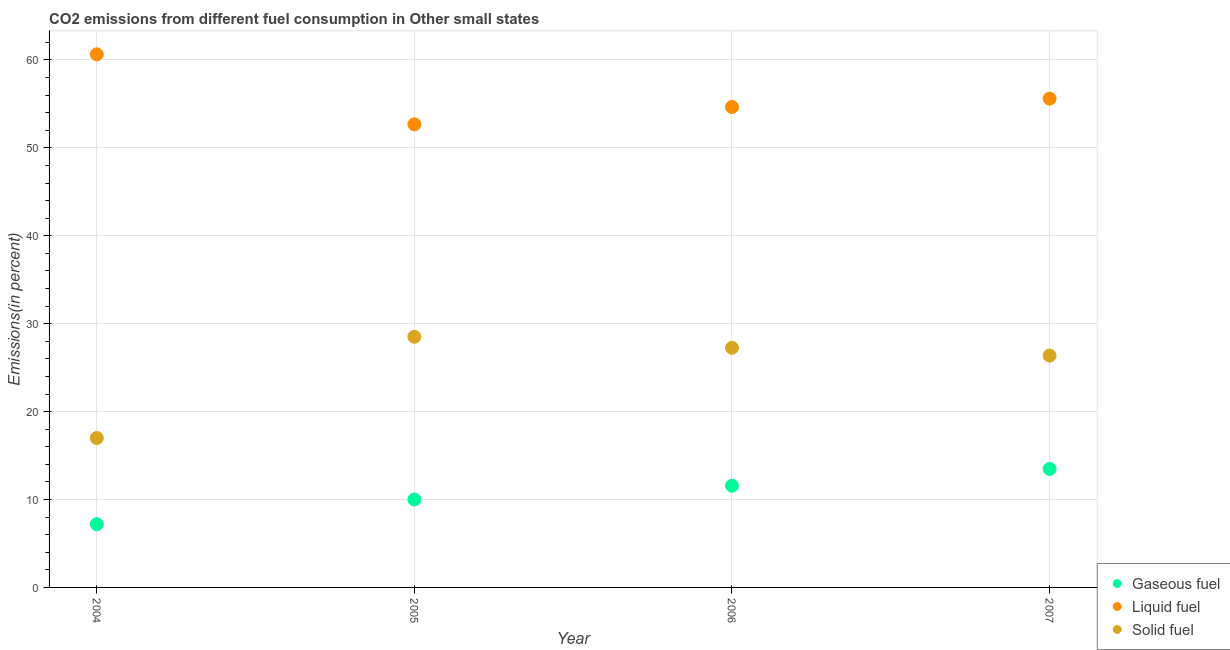How many different coloured dotlines are there?
Your answer should be very brief. 3. What is the percentage of gaseous fuel emission in 2007?
Provide a short and direct response. 13.48. Across all years, what is the maximum percentage of solid fuel emission?
Keep it short and to the point. 28.51. Across all years, what is the minimum percentage of gaseous fuel emission?
Your answer should be very brief. 7.19. In which year was the percentage of liquid fuel emission minimum?
Offer a very short reply. 2005. What is the total percentage of liquid fuel emission in the graph?
Make the answer very short. 223.56. What is the difference between the percentage of gaseous fuel emission in 2005 and that in 2006?
Provide a succinct answer. -1.57. What is the difference between the percentage of liquid fuel emission in 2007 and the percentage of gaseous fuel emission in 2004?
Your answer should be compact. 48.41. What is the average percentage of solid fuel emission per year?
Ensure brevity in your answer.  24.78. In the year 2007, what is the difference between the percentage of liquid fuel emission and percentage of solid fuel emission?
Offer a terse response. 29.23. What is the ratio of the percentage of gaseous fuel emission in 2005 to that in 2007?
Ensure brevity in your answer.  0.74. Is the percentage of solid fuel emission in 2006 less than that in 2007?
Offer a very short reply. No. Is the difference between the percentage of gaseous fuel emission in 2004 and 2007 greater than the difference between the percentage of solid fuel emission in 2004 and 2007?
Keep it short and to the point. Yes. What is the difference between the highest and the second highest percentage of gaseous fuel emission?
Offer a terse response. 1.91. What is the difference between the highest and the lowest percentage of solid fuel emission?
Your answer should be compact. 11.51. Is the sum of the percentage of gaseous fuel emission in 2004 and 2007 greater than the maximum percentage of solid fuel emission across all years?
Offer a terse response. No. Is it the case that in every year, the sum of the percentage of gaseous fuel emission and percentage of liquid fuel emission is greater than the percentage of solid fuel emission?
Ensure brevity in your answer.  Yes. Does the percentage of solid fuel emission monotonically increase over the years?
Offer a terse response. No. Is the percentage of liquid fuel emission strictly greater than the percentage of gaseous fuel emission over the years?
Ensure brevity in your answer.  Yes. Is the percentage of solid fuel emission strictly less than the percentage of gaseous fuel emission over the years?
Give a very brief answer. No. How many dotlines are there?
Keep it short and to the point. 3. How many years are there in the graph?
Your response must be concise. 4. Are the values on the major ticks of Y-axis written in scientific E-notation?
Make the answer very short. No. Does the graph contain grids?
Your response must be concise. Yes. Where does the legend appear in the graph?
Make the answer very short. Bottom right. What is the title of the graph?
Offer a terse response. CO2 emissions from different fuel consumption in Other small states. Does "Injury" appear as one of the legend labels in the graph?
Keep it short and to the point. No. What is the label or title of the Y-axis?
Your response must be concise. Emissions(in percent). What is the Emissions(in percent) in Gaseous fuel in 2004?
Your response must be concise. 7.19. What is the Emissions(in percent) in Liquid fuel in 2004?
Keep it short and to the point. 60.64. What is the Emissions(in percent) in Solid fuel in 2004?
Your response must be concise. 17. What is the Emissions(in percent) in Gaseous fuel in 2005?
Ensure brevity in your answer.  10. What is the Emissions(in percent) of Liquid fuel in 2005?
Your answer should be compact. 52.68. What is the Emissions(in percent) in Solid fuel in 2005?
Offer a terse response. 28.51. What is the Emissions(in percent) of Gaseous fuel in 2006?
Offer a terse response. 11.57. What is the Emissions(in percent) in Liquid fuel in 2006?
Provide a short and direct response. 54.65. What is the Emissions(in percent) of Solid fuel in 2006?
Provide a succinct answer. 27.26. What is the Emissions(in percent) of Gaseous fuel in 2007?
Provide a succinct answer. 13.48. What is the Emissions(in percent) in Liquid fuel in 2007?
Make the answer very short. 55.6. What is the Emissions(in percent) in Solid fuel in 2007?
Your response must be concise. 26.37. Across all years, what is the maximum Emissions(in percent) of Gaseous fuel?
Your answer should be compact. 13.48. Across all years, what is the maximum Emissions(in percent) of Liquid fuel?
Make the answer very short. 60.64. Across all years, what is the maximum Emissions(in percent) in Solid fuel?
Make the answer very short. 28.51. Across all years, what is the minimum Emissions(in percent) in Gaseous fuel?
Give a very brief answer. 7.19. Across all years, what is the minimum Emissions(in percent) in Liquid fuel?
Your answer should be compact. 52.68. Across all years, what is the minimum Emissions(in percent) in Solid fuel?
Your answer should be very brief. 17. What is the total Emissions(in percent) in Gaseous fuel in the graph?
Your answer should be very brief. 42.24. What is the total Emissions(in percent) in Liquid fuel in the graph?
Provide a short and direct response. 223.56. What is the total Emissions(in percent) of Solid fuel in the graph?
Your response must be concise. 99.14. What is the difference between the Emissions(in percent) of Gaseous fuel in 2004 and that in 2005?
Keep it short and to the point. -2.81. What is the difference between the Emissions(in percent) in Liquid fuel in 2004 and that in 2005?
Ensure brevity in your answer.  7.96. What is the difference between the Emissions(in percent) of Solid fuel in 2004 and that in 2005?
Ensure brevity in your answer.  -11.51. What is the difference between the Emissions(in percent) of Gaseous fuel in 2004 and that in 2006?
Your response must be concise. -4.38. What is the difference between the Emissions(in percent) in Liquid fuel in 2004 and that in 2006?
Provide a short and direct response. 5.99. What is the difference between the Emissions(in percent) of Solid fuel in 2004 and that in 2006?
Provide a succinct answer. -10.26. What is the difference between the Emissions(in percent) of Gaseous fuel in 2004 and that in 2007?
Give a very brief answer. -6.29. What is the difference between the Emissions(in percent) in Liquid fuel in 2004 and that in 2007?
Offer a terse response. 5.04. What is the difference between the Emissions(in percent) of Solid fuel in 2004 and that in 2007?
Your answer should be compact. -9.37. What is the difference between the Emissions(in percent) in Gaseous fuel in 2005 and that in 2006?
Make the answer very short. -1.57. What is the difference between the Emissions(in percent) in Liquid fuel in 2005 and that in 2006?
Your answer should be compact. -1.97. What is the difference between the Emissions(in percent) in Solid fuel in 2005 and that in 2006?
Offer a terse response. 1.25. What is the difference between the Emissions(in percent) of Gaseous fuel in 2005 and that in 2007?
Your response must be concise. -3.48. What is the difference between the Emissions(in percent) of Liquid fuel in 2005 and that in 2007?
Make the answer very short. -2.92. What is the difference between the Emissions(in percent) in Solid fuel in 2005 and that in 2007?
Give a very brief answer. 2.14. What is the difference between the Emissions(in percent) in Gaseous fuel in 2006 and that in 2007?
Give a very brief answer. -1.91. What is the difference between the Emissions(in percent) in Liquid fuel in 2006 and that in 2007?
Keep it short and to the point. -0.95. What is the difference between the Emissions(in percent) in Solid fuel in 2006 and that in 2007?
Provide a short and direct response. 0.89. What is the difference between the Emissions(in percent) in Gaseous fuel in 2004 and the Emissions(in percent) in Liquid fuel in 2005?
Your response must be concise. -45.48. What is the difference between the Emissions(in percent) of Gaseous fuel in 2004 and the Emissions(in percent) of Solid fuel in 2005?
Your response must be concise. -21.32. What is the difference between the Emissions(in percent) in Liquid fuel in 2004 and the Emissions(in percent) in Solid fuel in 2005?
Your answer should be compact. 32.13. What is the difference between the Emissions(in percent) in Gaseous fuel in 2004 and the Emissions(in percent) in Liquid fuel in 2006?
Keep it short and to the point. -47.46. What is the difference between the Emissions(in percent) in Gaseous fuel in 2004 and the Emissions(in percent) in Solid fuel in 2006?
Provide a short and direct response. -20.07. What is the difference between the Emissions(in percent) in Liquid fuel in 2004 and the Emissions(in percent) in Solid fuel in 2006?
Make the answer very short. 33.38. What is the difference between the Emissions(in percent) of Gaseous fuel in 2004 and the Emissions(in percent) of Liquid fuel in 2007?
Your answer should be compact. -48.41. What is the difference between the Emissions(in percent) of Gaseous fuel in 2004 and the Emissions(in percent) of Solid fuel in 2007?
Your answer should be very brief. -19.18. What is the difference between the Emissions(in percent) of Liquid fuel in 2004 and the Emissions(in percent) of Solid fuel in 2007?
Ensure brevity in your answer.  34.27. What is the difference between the Emissions(in percent) of Gaseous fuel in 2005 and the Emissions(in percent) of Liquid fuel in 2006?
Offer a terse response. -44.65. What is the difference between the Emissions(in percent) of Gaseous fuel in 2005 and the Emissions(in percent) of Solid fuel in 2006?
Your answer should be compact. -17.26. What is the difference between the Emissions(in percent) in Liquid fuel in 2005 and the Emissions(in percent) in Solid fuel in 2006?
Make the answer very short. 25.42. What is the difference between the Emissions(in percent) of Gaseous fuel in 2005 and the Emissions(in percent) of Liquid fuel in 2007?
Give a very brief answer. -45.6. What is the difference between the Emissions(in percent) in Gaseous fuel in 2005 and the Emissions(in percent) in Solid fuel in 2007?
Make the answer very short. -16.37. What is the difference between the Emissions(in percent) in Liquid fuel in 2005 and the Emissions(in percent) in Solid fuel in 2007?
Your response must be concise. 26.31. What is the difference between the Emissions(in percent) in Gaseous fuel in 2006 and the Emissions(in percent) in Liquid fuel in 2007?
Your answer should be compact. -44.03. What is the difference between the Emissions(in percent) of Gaseous fuel in 2006 and the Emissions(in percent) of Solid fuel in 2007?
Provide a short and direct response. -14.8. What is the difference between the Emissions(in percent) in Liquid fuel in 2006 and the Emissions(in percent) in Solid fuel in 2007?
Your answer should be compact. 28.28. What is the average Emissions(in percent) in Gaseous fuel per year?
Offer a terse response. 10.56. What is the average Emissions(in percent) in Liquid fuel per year?
Make the answer very short. 55.89. What is the average Emissions(in percent) of Solid fuel per year?
Ensure brevity in your answer.  24.78. In the year 2004, what is the difference between the Emissions(in percent) in Gaseous fuel and Emissions(in percent) in Liquid fuel?
Provide a succinct answer. -53.45. In the year 2004, what is the difference between the Emissions(in percent) in Gaseous fuel and Emissions(in percent) in Solid fuel?
Provide a succinct answer. -9.81. In the year 2004, what is the difference between the Emissions(in percent) in Liquid fuel and Emissions(in percent) in Solid fuel?
Give a very brief answer. 43.64. In the year 2005, what is the difference between the Emissions(in percent) of Gaseous fuel and Emissions(in percent) of Liquid fuel?
Ensure brevity in your answer.  -42.67. In the year 2005, what is the difference between the Emissions(in percent) in Gaseous fuel and Emissions(in percent) in Solid fuel?
Your answer should be compact. -18.51. In the year 2005, what is the difference between the Emissions(in percent) in Liquid fuel and Emissions(in percent) in Solid fuel?
Provide a short and direct response. 24.17. In the year 2006, what is the difference between the Emissions(in percent) of Gaseous fuel and Emissions(in percent) of Liquid fuel?
Offer a very short reply. -43.08. In the year 2006, what is the difference between the Emissions(in percent) in Gaseous fuel and Emissions(in percent) in Solid fuel?
Offer a very short reply. -15.69. In the year 2006, what is the difference between the Emissions(in percent) of Liquid fuel and Emissions(in percent) of Solid fuel?
Offer a terse response. 27.39. In the year 2007, what is the difference between the Emissions(in percent) of Gaseous fuel and Emissions(in percent) of Liquid fuel?
Offer a very short reply. -42.12. In the year 2007, what is the difference between the Emissions(in percent) in Gaseous fuel and Emissions(in percent) in Solid fuel?
Keep it short and to the point. -12.89. In the year 2007, what is the difference between the Emissions(in percent) in Liquid fuel and Emissions(in percent) in Solid fuel?
Keep it short and to the point. 29.23. What is the ratio of the Emissions(in percent) of Gaseous fuel in 2004 to that in 2005?
Keep it short and to the point. 0.72. What is the ratio of the Emissions(in percent) in Liquid fuel in 2004 to that in 2005?
Your answer should be compact. 1.15. What is the ratio of the Emissions(in percent) of Solid fuel in 2004 to that in 2005?
Provide a succinct answer. 0.6. What is the ratio of the Emissions(in percent) in Gaseous fuel in 2004 to that in 2006?
Your response must be concise. 0.62. What is the ratio of the Emissions(in percent) of Liquid fuel in 2004 to that in 2006?
Your answer should be very brief. 1.11. What is the ratio of the Emissions(in percent) of Solid fuel in 2004 to that in 2006?
Give a very brief answer. 0.62. What is the ratio of the Emissions(in percent) in Gaseous fuel in 2004 to that in 2007?
Give a very brief answer. 0.53. What is the ratio of the Emissions(in percent) in Liquid fuel in 2004 to that in 2007?
Your answer should be very brief. 1.09. What is the ratio of the Emissions(in percent) of Solid fuel in 2004 to that in 2007?
Offer a terse response. 0.64. What is the ratio of the Emissions(in percent) of Gaseous fuel in 2005 to that in 2006?
Keep it short and to the point. 0.86. What is the ratio of the Emissions(in percent) of Liquid fuel in 2005 to that in 2006?
Make the answer very short. 0.96. What is the ratio of the Emissions(in percent) in Solid fuel in 2005 to that in 2006?
Make the answer very short. 1.05. What is the ratio of the Emissions(in percent) in Gaseous fuel in 2005 to that in 2007?
Your answer should be compact. 0.74. What is the ratio of the Emissions(in percent) of Liquid fuel in 2005 to that in 2007?
Offer a terse response. 0.95. What is the ratio of the Emissions(in percent) of Solid fuel in 2005 to that in 2007?
Provide a succinct answer. 1.08. What is the ratio of the Emissions(in percent) of Gaseous fuel in 2006 to that in 2007?
Give a very brief answer. 0.86. What is the ratio of the Emissions(in percent) of Liquid fuel in 2006 to that in 2007?
Your response must be concise. 0.98. What is the ratio of the Emissions(in percent) in Solid fuel in 2006 to that in 2007?
Your answer should be very brief. 1.03. What is the difference between the highest and the second highest Emissions(in percent) in Gaseous fuel?
Keep it short and to the point. 1.91. What is the difference between the highest and the second highest Emissions(in percent) in Liquid fuel?
Ensure brevity in your answer.  5.04. What is the difference between the highest and the second highest Emissions(in percent) in Solid fuel?
Provide a short and direct response. 1.25. What is the difference between the highest and the lowest Emissions(in percent) of Gaseous fuel?
Your answer should be compact. 6.29. What is the difference between the highest and the lowest Emissions(in percent) of Liquid fuel?
Your response must be concise. 7.96. What is the difference between the highest and the lowest Emissions(in percent) in Solid fuel?
Your answer should be compact. 11.51. 